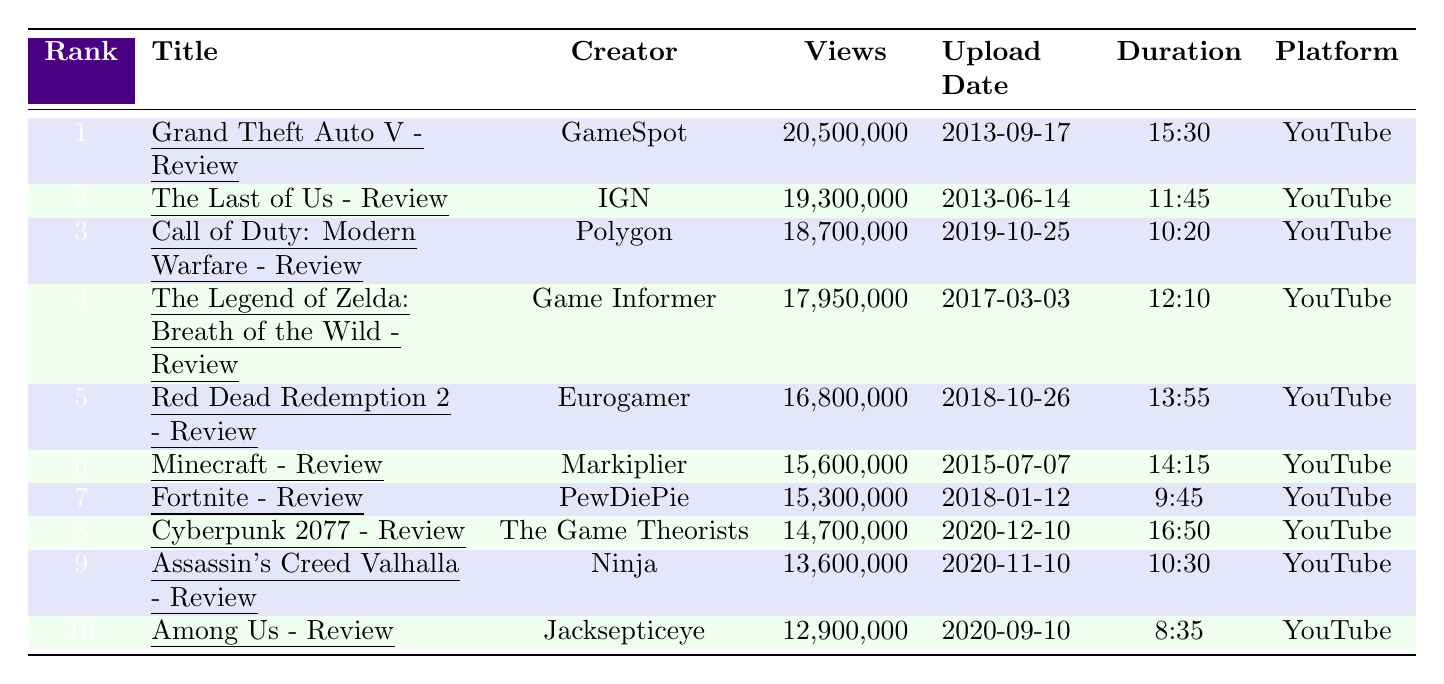What is the title of the most viewed game review video? The most viewed game review video is listed at rank 1, which is "Grand Theft Auto V - Review."
Answer: Grand Theft Auto V - Review Which creator has the second most viewed game review video? The second most viewed video is "The Last of Us - Review," which was created by IGN.
Answer: IGN What is the total number of views for the top three game review videos? The views for the top three videos are 20,500,000 + 19,300,000 + 18,700,000 = 58,500,000.
Answer: 58,500,000 How many views does the video for "Among Us - Review" have compared to "Fortnite - Review"? "Among Us - Review" has 12,900,000 views and "Fortnite - Review" has 15,300,000 views. The difference is 15,300,000 - 12,900,000 = 2,400,000 views.
Answer: 2,400,000 What is the average view count of the top 5 videos? The view counts for the top 5 videos are 20,500,000, 19,300,000, 18,700,000, 17,950,000, and 16,800,000. Adding these gives 92,250,000 views. Dividing by 5 gives an average of 92,250,000 / 5 = 18,450,000.
Answer: 18,450,000 Is there a video uploaded in 2020 that has more views than "Minecraft - Review"? "Minecraft - Review" has 15,600,000 views. The videos uploaded in 2020 are "Cyberpunk 2077 - Review" (14,700,000), "Assassin's Creed Valhalla - Review" (13,600,000), and "Among Us - Review" (12,900,000). All are less than 15,600,000.
Answer: No Which creator has the longest duration video among the top 10? The video with the longest duration is "Cyberpunk 2077 - Review" at 16:50. I can confirm this by comparing all durations listed.
Answer: Cyberpunk 2077 - Review What is the average duration of the top 10 game review videos in minutes? Converting the durations into minutes: 15.5, 11.75, 10.33, 12.17, 13.92, 14.25, 9.75, 16.83, 10.5, and 8.58. Summing these gives about 131.58 minutes. Dividing by 10 gives an average of about 13.16 minutes.
Answer: 13.16 minutes How many of the top 10 game review videos were created by unique creators? The creators listed are GameSpot, IGN, Polygon, Game Informer, Eurogamer, Markiplier, PewDiePie, The Game Theorists, Ninja, and Jacksepticeye – a total of 10 unique creators.
Answer: 10 Which game review video has the lowest view count? The video with the lowest view count is "Among Us - Review," which has 12,900,000 views, as observed at rank 10 of the table.
Answer: Among Us - Review 